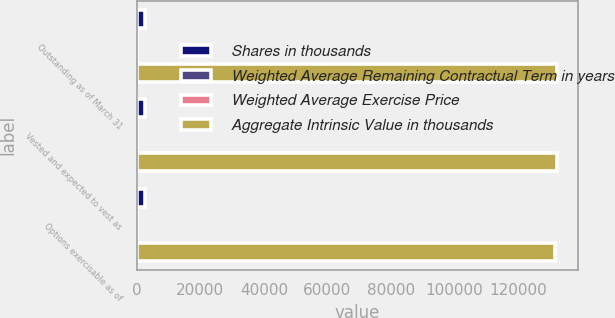<chart> <loc_0><loc_0><loc_500><loc_500><stacked_bar_chart><ecel><fcel>Outstanding as of March 31<fcel>Vested and expected to vest as<fcel>Options exercisable as of<nl><fcel>Shares in thousands<fcel>2623<fcel>2623<fcel>2597<nl><fcel>Weighted Average Remaining Contractual Term in years<fcel>20.06<fcel>20.06<fcel>19.79<nl><fcel>Weighted Average Exercise Price<fcel>3.64<fcel>3.64<fcel>3.64<nl><fcel>Aggregate Intrinsic Value in thousands<fcel>132217<fcel>132216<fcel>131585<nl></chart> 